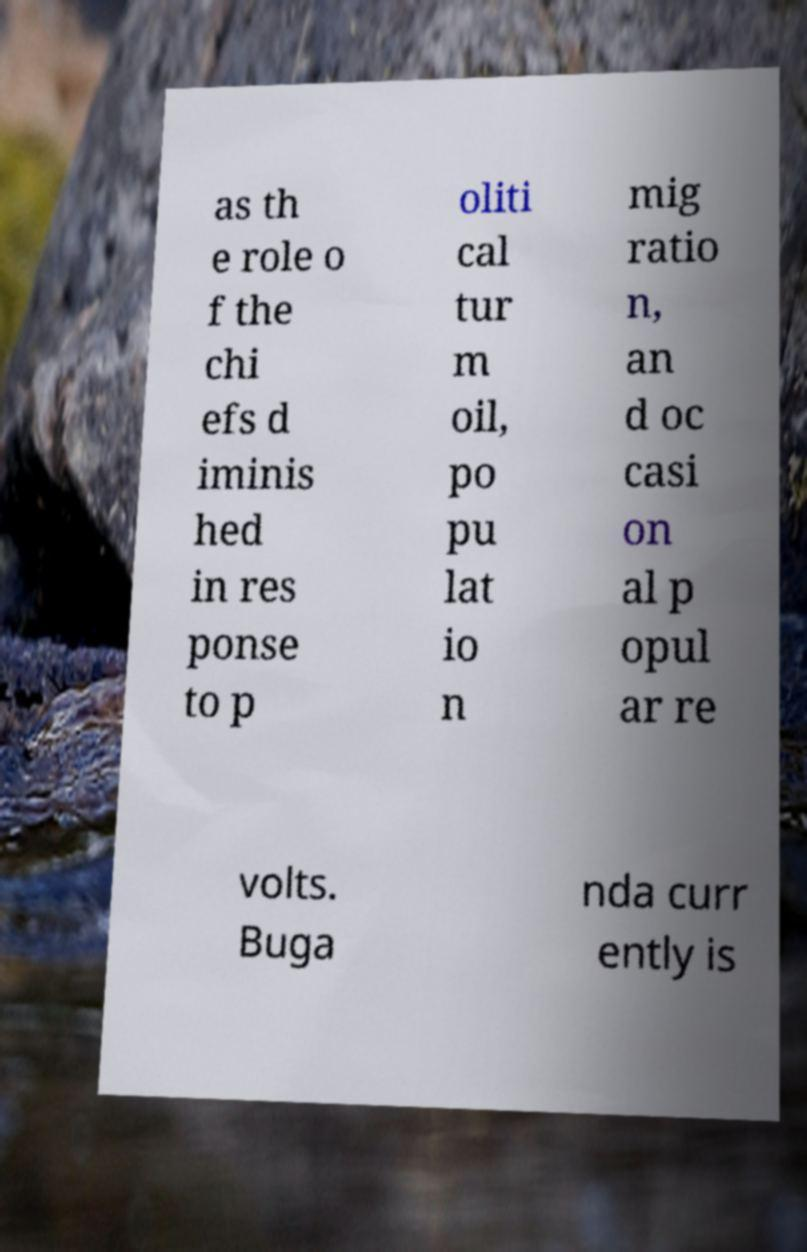For documentation purposes, I need the text within this image transcribed. Could you provide that? as th e role o f the chi efs d iminis hed in res ponse to p oliti cal tur m oil, po pu lat io n mig ratio n, an d oc casi on al p opul ar re volts. Buga nda curr ently is 